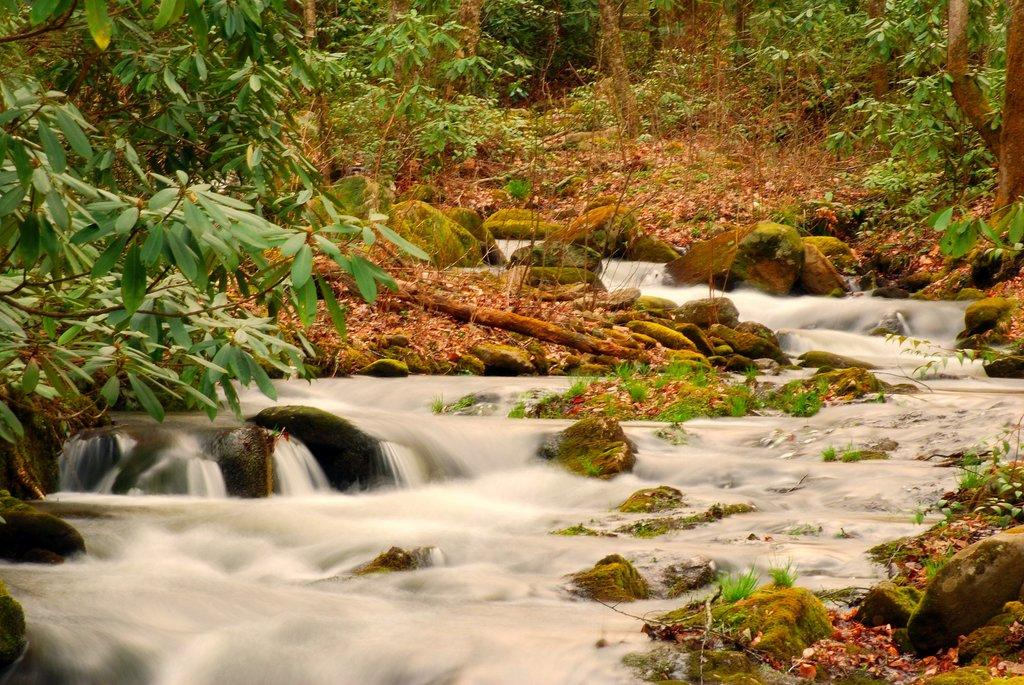What type of vegetation can be seen in the image? There are plants, trees, and grass visible in the image. What natural features are present in the image? There are rocks and a river visible in the image. What is on the ground in the image? Leaves are present on the ground in the image. What shape is the question mark on the ground in the image? There is no question mark present on the ground in the image. What season is it in the image, given the presence of falling leaves? The presence of leaves on the ground does not necessarily indicate a specific season, as leaves can fall at different times of the year depending on the type of tree. 